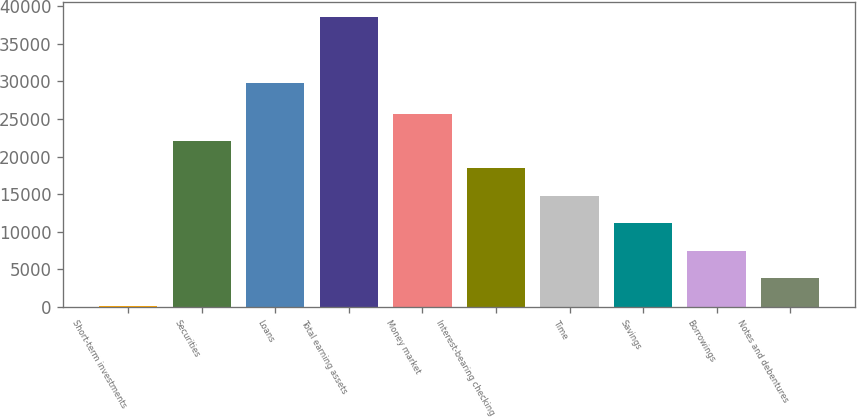<chart> <loc_0><loc_0><loc_500><loc_500><bar_chart><fcel>Short-term investments<fcel>Securities<fcel>Loans<fcel>Total earning assets<fcel>Money market<fcel>Interest-bearing checking<fcel>Time<fcel>Savings<fcel>Borrowings<fcel>Notes and debentures<nl><fcel>181.7<fcel>22071.4<fcel>29744.9<fcel>38596<fcel>25719.7<fcel>18423.1<fcel>14774.8<fcel>11126.5<fcel>7478.26<fcel>3829.98<nl></chart> 